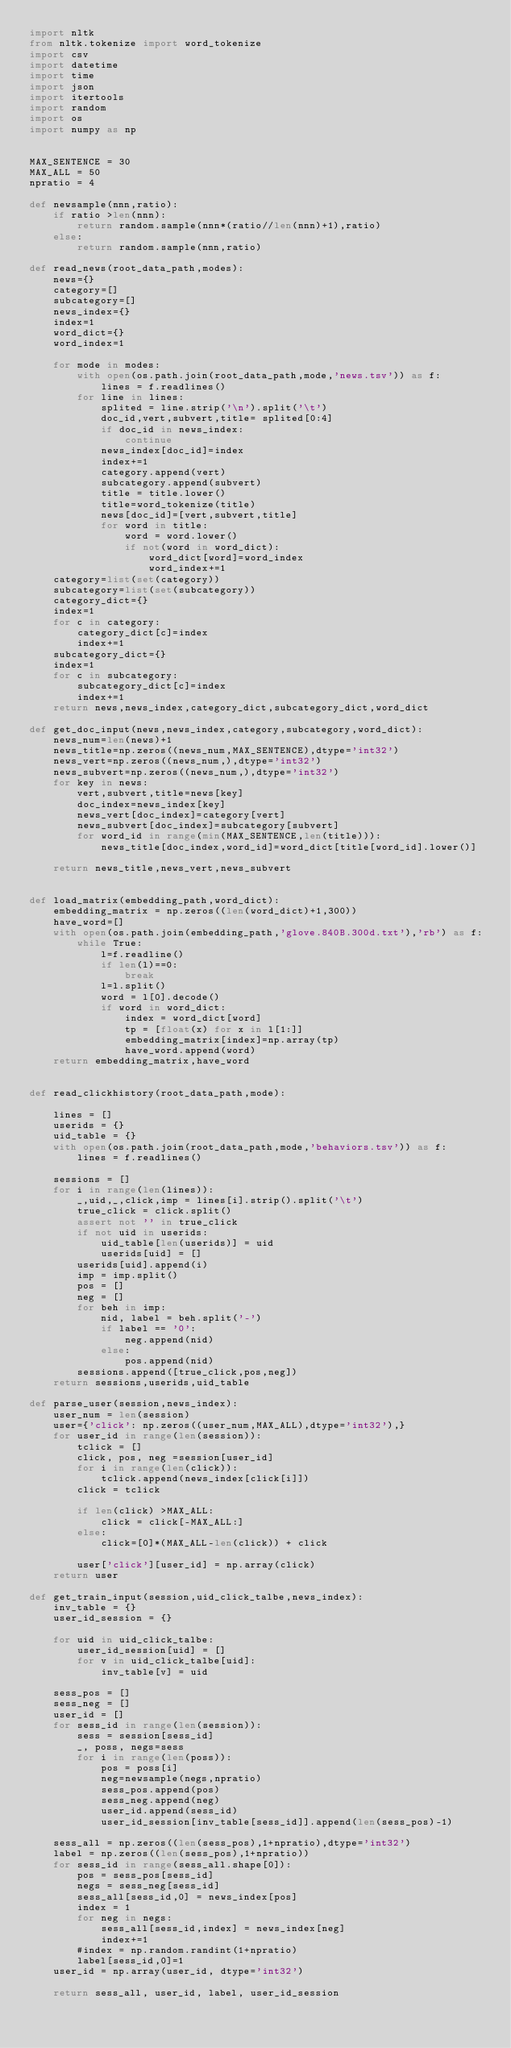Convert code to text. <code><loc_0><loc_0><loc_500><loc_500><_Python_>import nltk 
from nltk.tokenize import word_tokenize
import csv
import datetime
import time
import json
import itertools
import random
import os
import numpy as np


MAX_SENTENCE = 30
MAX_ALL = 50
npratio = 4

def newsample(nnn,ratio):
    if ratio >len(nnn):
        return random.sample(nnn*(ratio//len(nnn)+1),ratio)
    else:
        return random.sample(nnn,ratio)

def read_news(root_data_path,modes):
    news={}
    category=[]
    subcategory=[]
    news_index={}
    index=1
    word_dict={}
    word_index=1
    
    for mode in modes:
        with open(os.path.join(root_data_path,mode,'news.tsv')) as f:
            lines = f.readlines()
        for line in lines:
            splited = line.strip('\n').split('\t')
            doc_id,vert,subvert,title= splited[0:4]
            if doc_id in news_index:
                continue
            news_index[doc_id]=index
            index+=1
            category.append(vert)
            subcategory.append(subvert)
            title = title.lower()
            title=word_tokenize(title)
            news[doc_id]=[vert,subvert,title]
            for word in title:
                word = word.lower()
                if not(word in word_dict):
                    word_dict[word]=word_index
                    word_index+=1
    category=list(set(category))
    subcategory=list(set(subcategory))
    category_dict={}
    index=1
    for c in category:
        category_dict[c]=index
        index+=1
    subcategory_dict={}
    index=1
    for c in subcategory:
        subcategory_dict[c]=index
        index+=1
    return news,news_index,category_dict,subcategory_dict,word_dict

def get_doc_input(news,news_index,category,subcategory,word_dict):
    news_num=len(news)+1
    news_title=np.zeros((news_num,MAX_SENTENCE),dtype='int32')
    news_vert=np.zeros((news_num,),dtype='int32')
    news_subvert=np.zeros((news_num,),dtype='int32')
    for key in news:    
        vert,subvert,title=news[key]
        doc_index=news_index[key]
        news_vert[doc_index]=category[vert]
        news_subvert[doc_index]=subcategory[subvert]
        for word_id in range(min(MAX_SENTENCE,len(title))):
            news_title[doc_index,word_id]=word_dict[title[word_id].lower()]
        
    return news_title,news_vert,news_subvert


def load_matrix(embedding_path,word_dict):
    embedding_matrix = np.zeros((len(word_dict)+1,300))
    have_word=[]
    with open(os.path.join(embedding_path,'glove.840B.300d.txt'),'rb') as f:
        while True:
            l=f.readline()
            if len(l)==0:
                break
            l=l.split()
            word = l[0].decode()
            if word in word_dict:
                index = word_dict[word]
                tp = [float(x) for x in l[1:]]
                embedding_matrix[index]=np.array(tp)
                have_word.append(word)
    return embedding_matrix,have_word


def read_clickhistory(root_data_path,mode):
    
    lines = []
    userids = {}
    uid_table = {}
    with open(os.path.join(root_data_path,mode,'behaviors.tsv')) as f:
        lines = f.readlines()
        
    sessions = []
    for i in range(len(lines)):
        _,uid,_,click,imp = lines[i].strip().split('\t')
        true_click = click.split()
        assert not '' in true_click
        if not uid in userids:
            uid_table[len(userids)] = uid
            userids[uid] = []
        userids[uid].append(i)
        imp = imp.split()
        pos = []
        neg = []
        for beh in imp:
            nid, label = beh.split('-')
            if label == '0':
                neg.append(nid)
            else:
                pos.append(nid)
        sessions.append([true_click,pos,neg])
    return sessions,userids,uid_table

def parse_user(session,news_index):
    user_num = len(session)
    user={'click': np.zeros((user_num,MAX_ALL),dtype='int32'),}
    for user_id in range(len(session)):
        tclick = []
        click, pos, neg =session[user_id]
        for i in range(len(click)):
            tclick.append(news_index[click[i]])
        click = tclick

        if len(click) >MAX_ALL:
            click = click[-MAX_ALL:]
        else:
            click=[0]*(MAX_ALL-len(click)) + click
            
        user['click'][user_id] = np.array(click)
    return user

def get_train_input(session,uid_click_talbe,news_index):
    inv_table = {}
    user_id_session = {}

    for uid in uid_click_talbe:
        user_id_session[uid] = []
        for v in uid_click_talbe[uid]:
            inv_table[v] = uid
    
    sess_pos = []
    sess_neg = []
    user_id = []
    for sess_id in range(len(session)):
        sess = session[sess_id]
        _, poss, negs=sess
        for i in range(len(poss)):
            pos = poss[i]
            neg=newsample(negs,npratio)
            sess_pos.append(pos)
            sess_neg.append(neg)
            user_id.append(sess_id)                
            user_id_session[inv_table[sess_id]].append(len(sess_pos)-1)
            
    sess_all = np.zeros((len(sess_pos),1+npratio),dtype='int32')
    label = np.zeros((len(sess_pos),1+npratio))
    for sess_id in range(sess_all.shape[0]):
        pos = sess_pos[sess_id]
        negs = sess_neg[sess_id]
        sess_all[sess_id,0] = news_index[pos]
        index = 1
        for neg in negs:
            sess_all[sess_id,index] = news_index[neg]
            index+=1
        #index = np.random.randint(1+npratio)
        label[sess_id,0]=1
    user_id = np.array(user_id, dtype='int32')
    
    return sess_all, user_id, label, user_id_session
</code> 